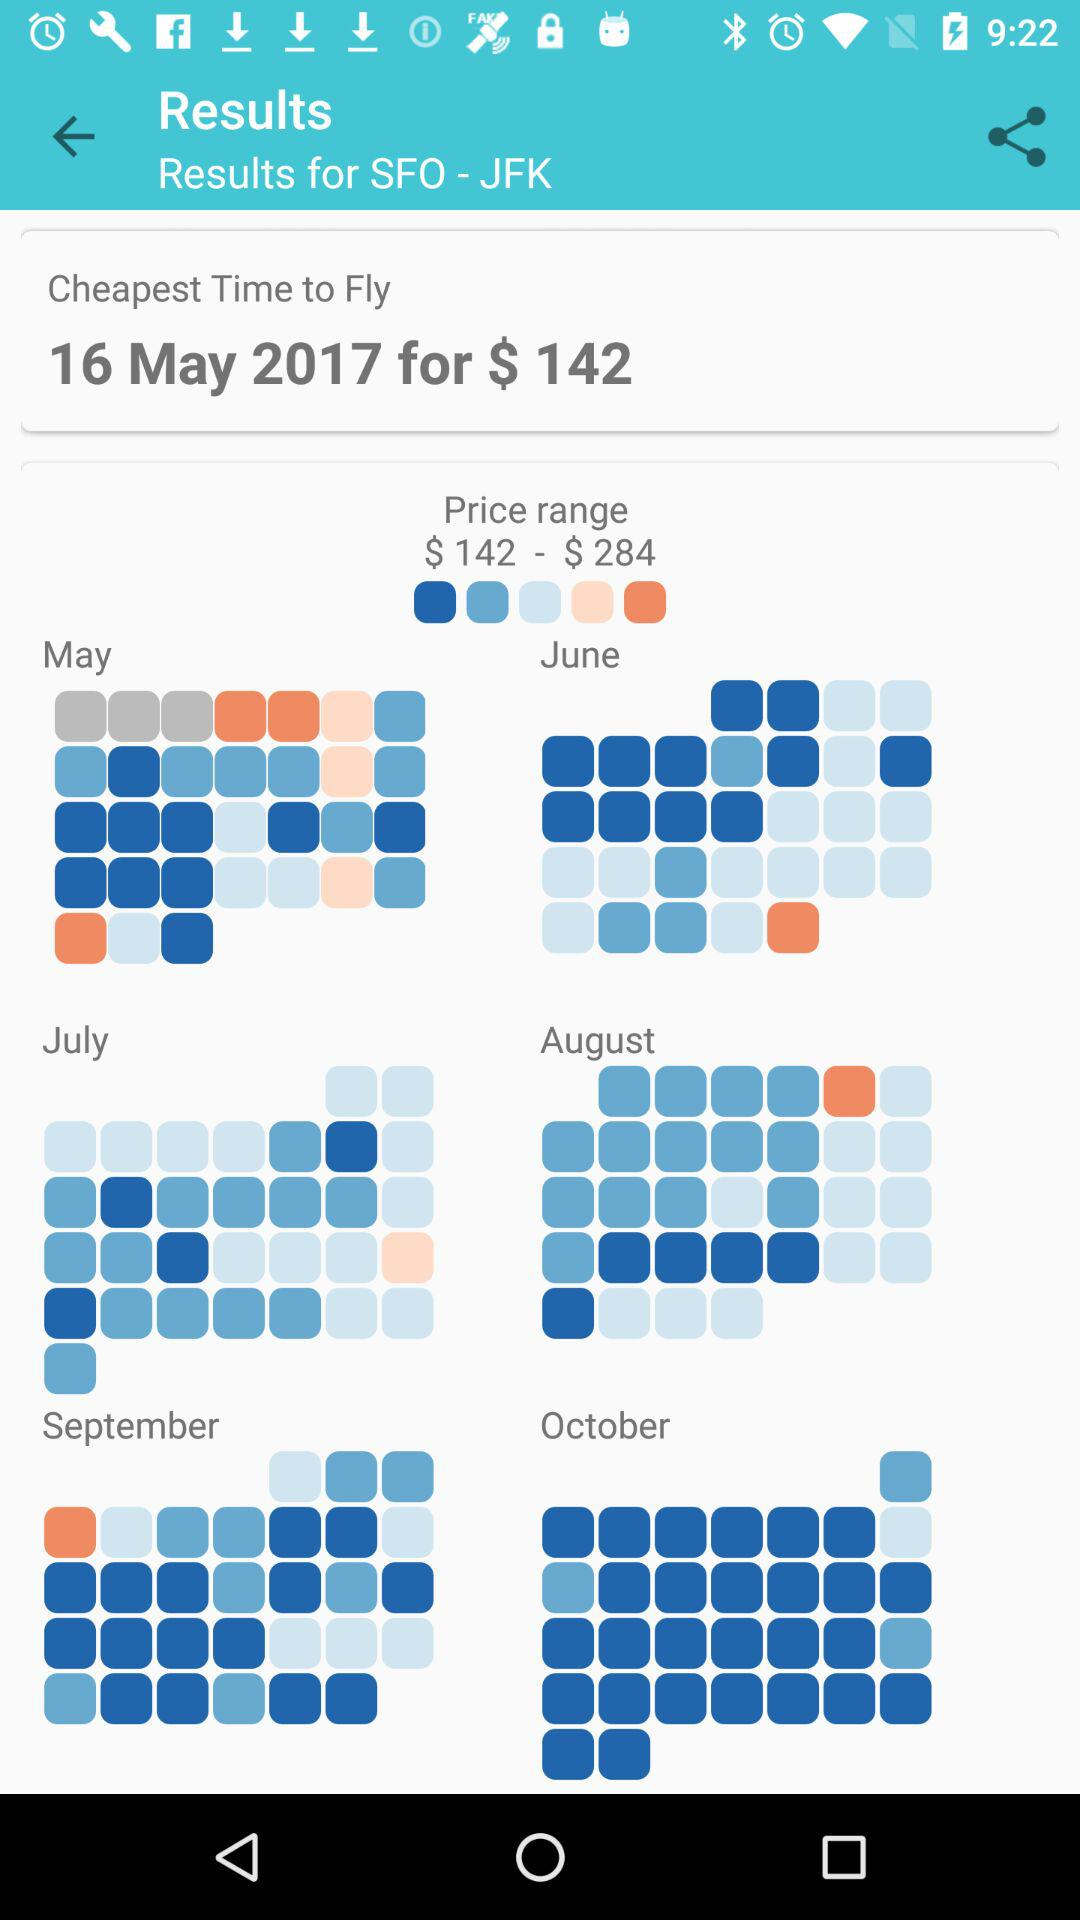How much more expensive is the highest price compared to the lowest price?
Answer the question using a single word or phrase. $142 